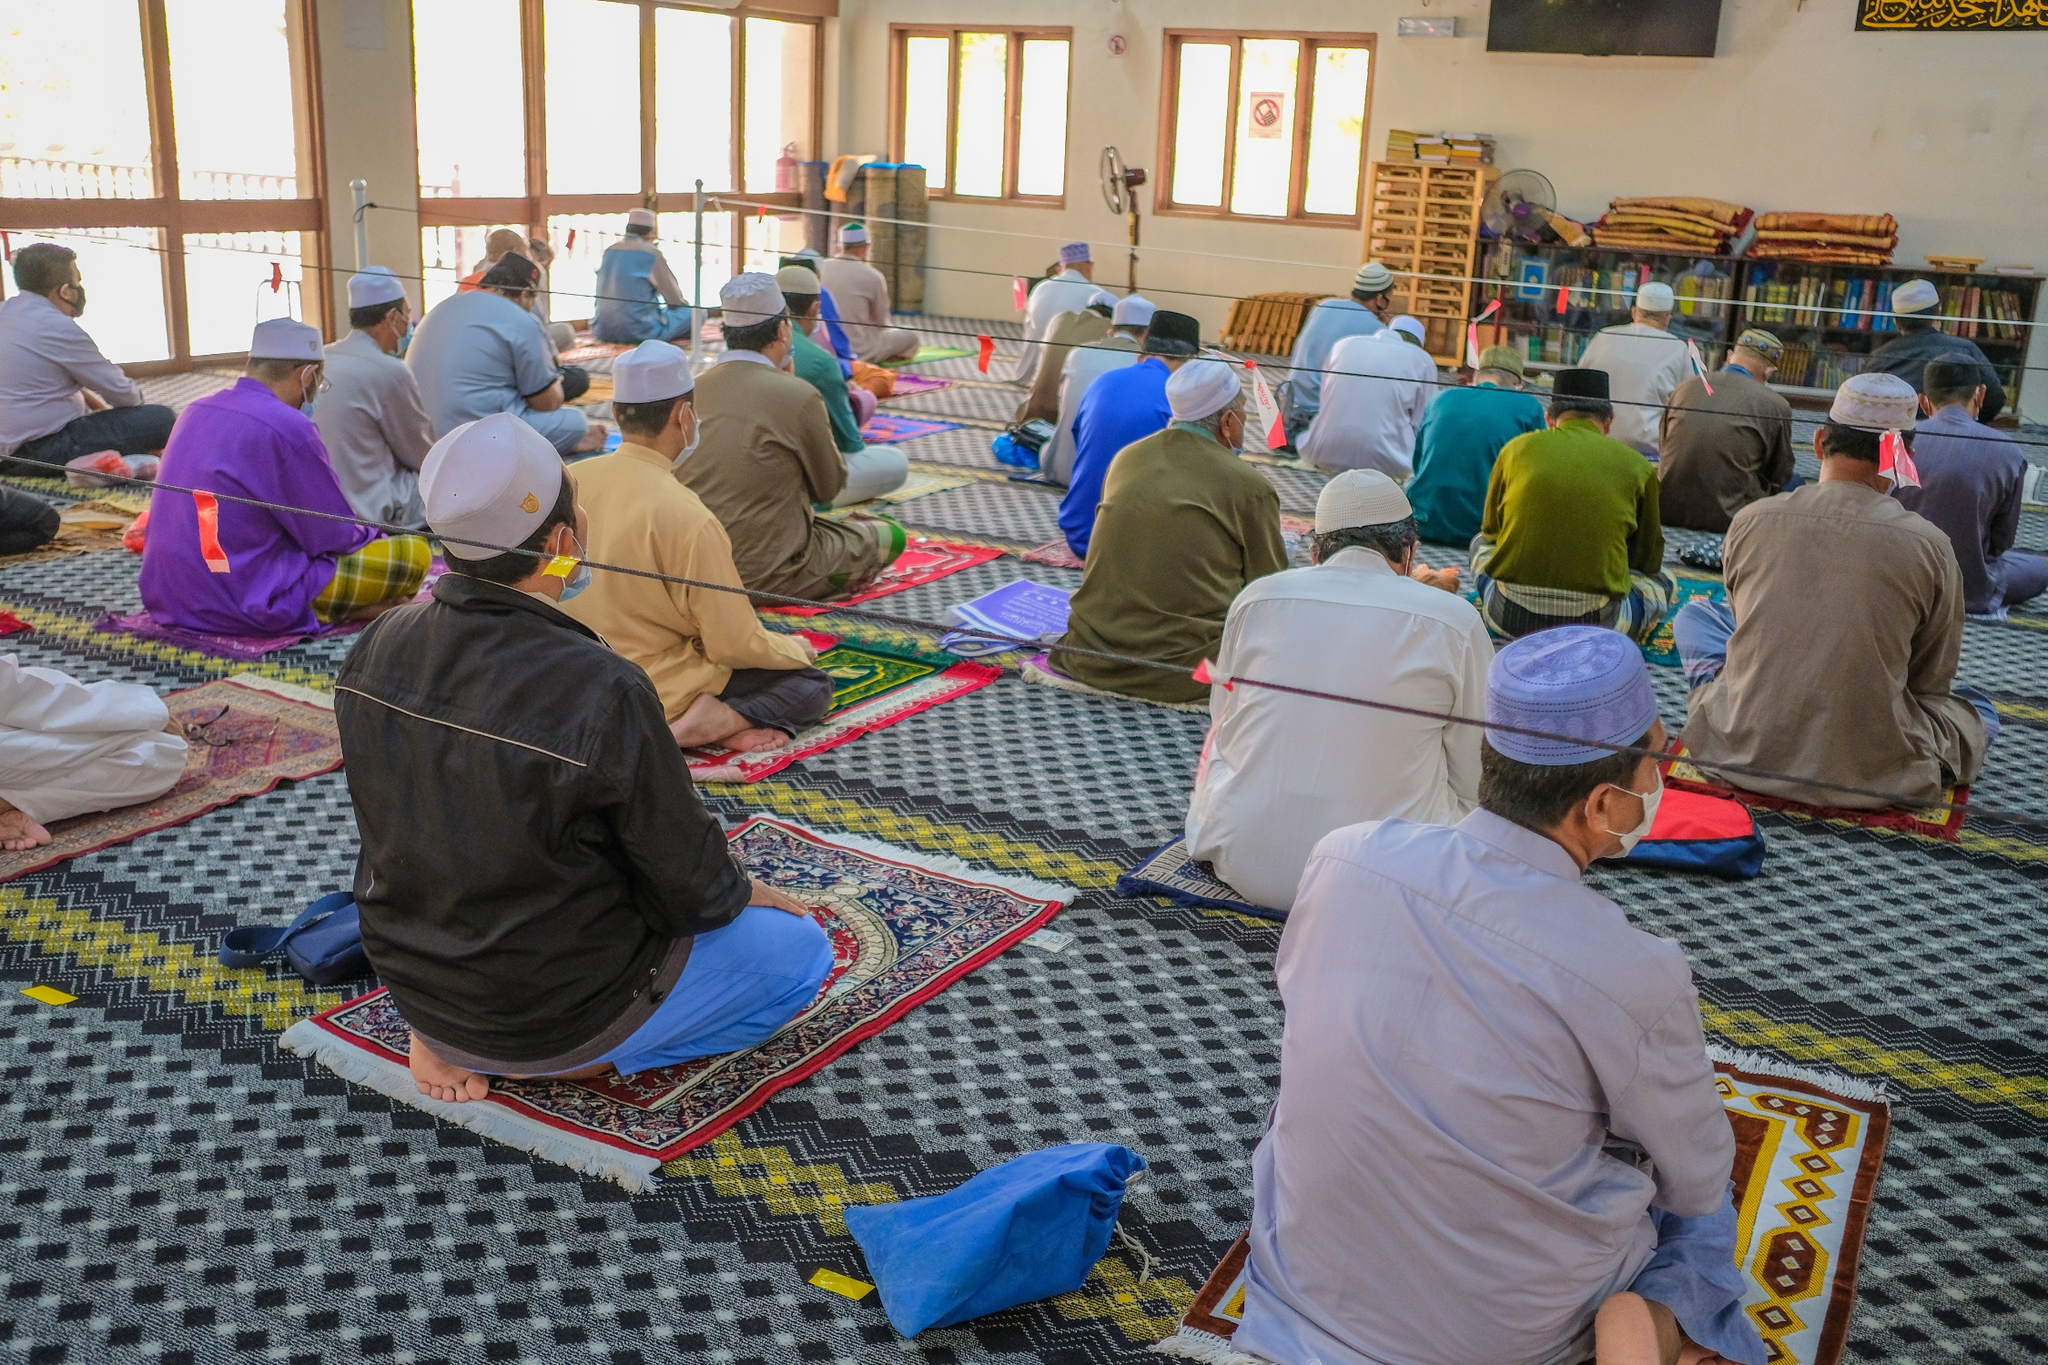Can you elaborate on the elements of the picture provided? The image depicts a moment of collective devotion inside a mosque. A group of individuals, dressed in traditional attire, are engaged in prayer. They are seated evenly on a variety of colorful prayer mats that create an intricate pattern on the floor. The mosque’s interior is spacious, with high ceilings and natural light entering through large windows, which highlights the serene and contemplative atmosphere. The walls are adorned with bookshelves filled with religious texts, suggesting that this place serves not only as a space for prayer but also for learning and community gathering. The image captures a moment of unity and spiritual reflection, emblematic of the mosque's role in the community. 